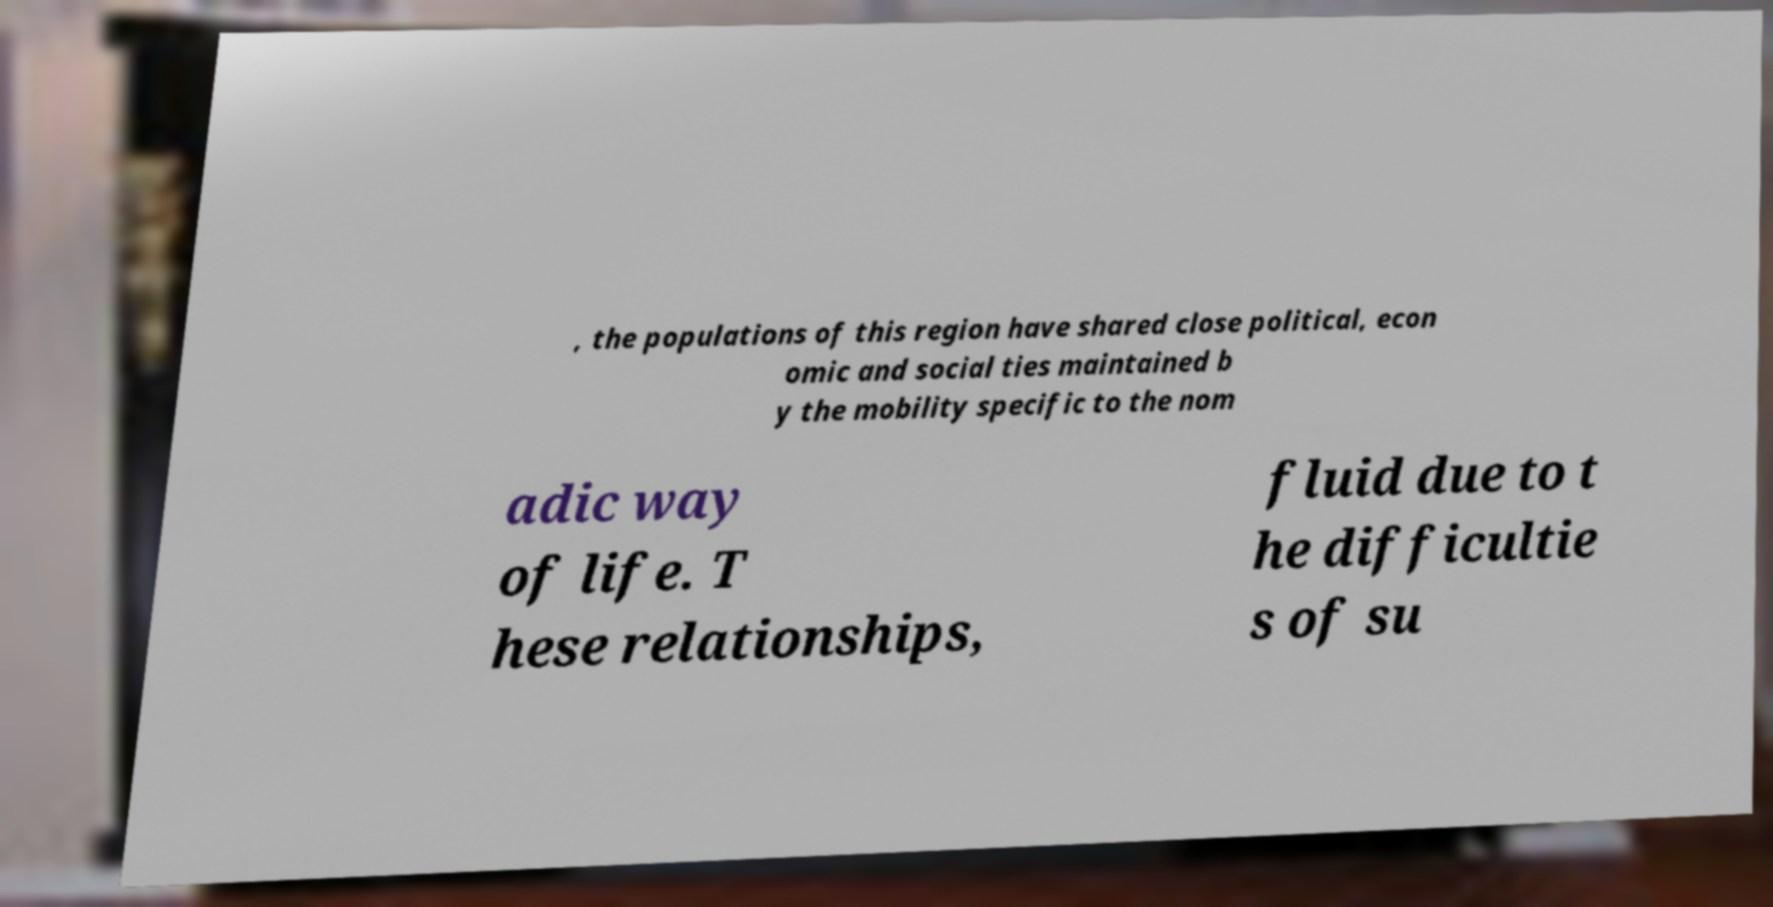What messages or text are displayed in this image? I need them in a readable, typed format. , the populations of this region have shared close political, econ omic and social ties maintained b y the mobility specific to the nom adic way of life. T hese relationships, fluid due to t he difficultie s of su 